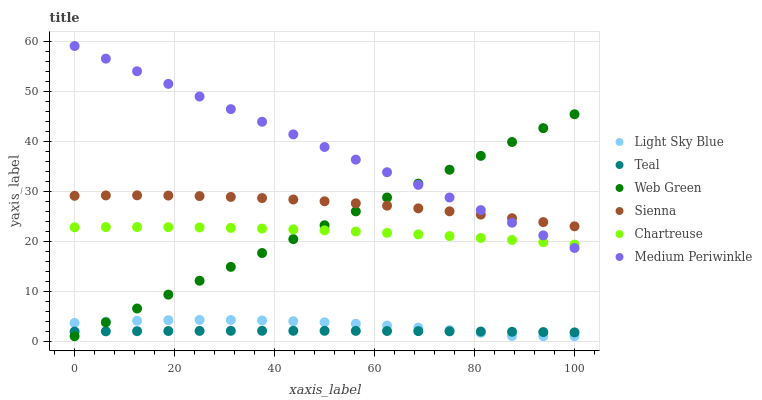Does Teal have the minimum area under the curve?
Answer yes or no. Yes. Does Medium Periwinkle have the maximum area under the curve?
Answer yes or no. Yes. Does Web Green have the minimum area under the curve?
Answer yes or no. No. Does Web Green have the maximum area under the curve?
Answer yes or no. No. Is Web Green the smoothest?
Answer yes or no. Yes. Is Light Sky Blue the roughest?
Answer yes or no. Yes. Is Sienna the smoothest?
Answer yes or no. No. Is Sienna the roughest?
Answer yes or no. No. Does Web Green have the lowest value?
Answer yes or no. Yes. Does Sienna have the lowest value?
Answer yes or no. No. Does Medium Periwinkle have the highest value?
Answer yes or no. Yes. Does Web Green have the highest value?
Answer yes or no. No. Is Teal less than Chartreuse?
Answer yes or no. Yes. Is Medium Periwinkle greater than Light Sky Blue?
Answer yes or no. Yes. Does Web Green intersect Medium Periwinkle?
Answer yes or no. Yes. Is Web Green less than Medium Periwinkle?
Answer yes or no. No. Is Web Green greater than Medium Periwinkle?
Answer yes or no. No. Does Teal intersect Chartreuse?
Answer yes or no. No. 